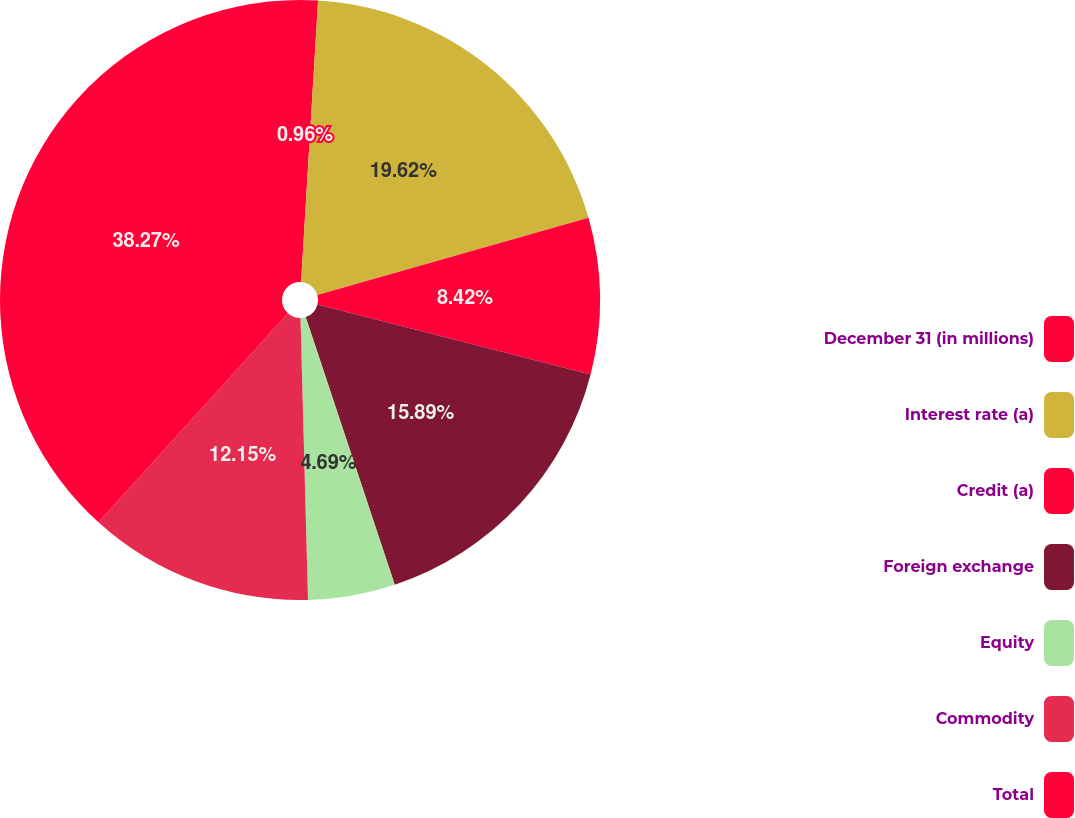<chart> <loc_0><loc_0><loc_500><loc_500><pie_chart><fcel>December 31 (in millions)<fcel>Interest rate (a)<fcel>Credit (a)<fcel>Foreign exchange<fcel>Equity<fcel>Commodity<fcel>Total<nl><fcel>0.96%<fcel>19.62%<fcel>8.42%<fcel>15.89%<fcel>4.69%<fcel>12.15%<fcel>38.28%<nl></chart> 